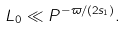Convert formula to latex. <formula><loc_0><loc_0><loc_500><loc_500>L _ { 0 } \ll P ^ { - \varpi / ( 2 s _ { 1 } ) } .</formula> 